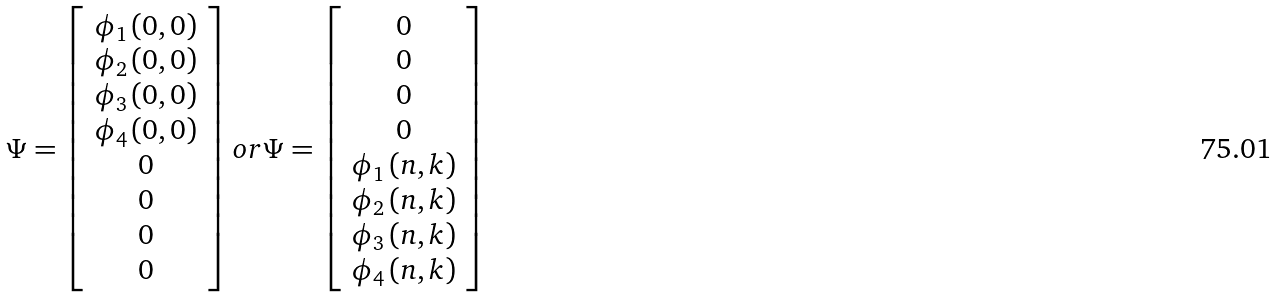<formula> <loc_0><loc_0><loc_500><loc_500>\Psi = \left [ \begin{array} { c } \phi _ { 1 } \left ( 0 , 0 \right ) \\ \phi _ { 2 } \left ( 0 , 0 \right ) \\ \phi _ { 3 } \left ( 0 , 0 \right ) \\ \phi _ { 4 } \left ( 0 , 0 \right ) \\ 0 \\ 0 \\ 0 \\ 0 \end{array} \right ] o r \Psi = \left [ \begin{array} { c } 0 \\ 0 \\ 0 \\ 0 \\ \phi _ { 1 } \left ( n , k \right ) \\ \phi _ { 2 } \left ( n , k \right ) \\ \phi _ { 3 } \left ( n , k \right ) \\ \phi _ { 4 } \left ( n , k \right ) \end{array} \right ]</formula> 